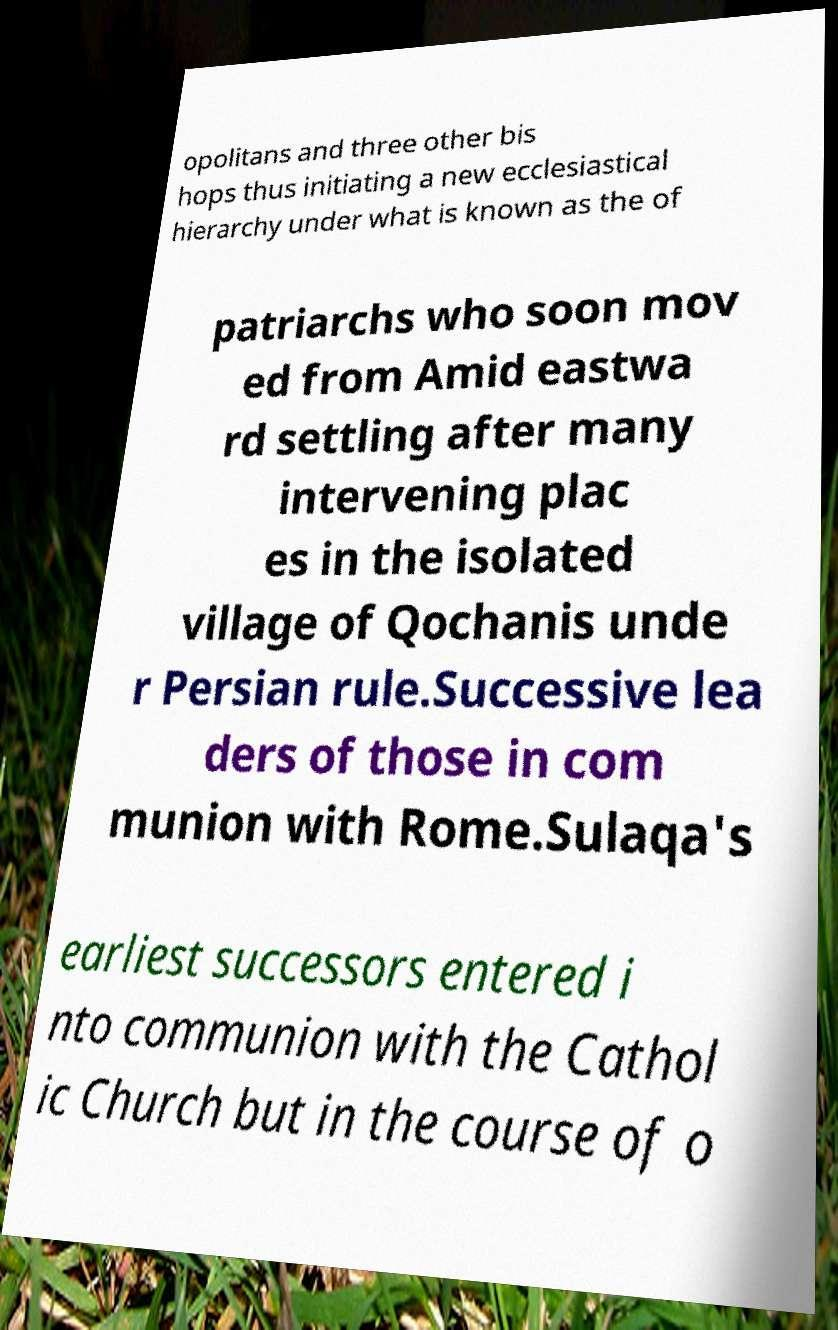Please identify and transcribe the text found in this image. opolitans and three other bis hops thus initiating a new ecclesiastical hierarchy under what is known as the of patriarchs who soon mov ed from Amid eastwa rd settling after many intervening plac es in the isolated village of Qochanis unde r Persian rule.Successive lea ders of those in com munion with Rome.Sulaqa's earliest successors entered i nto communion with the Cathol ic Church but in the course of o 